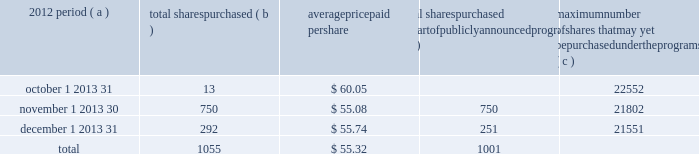Part ii item 5 2013 market for registrant 2019s common equity , related stockholder matters and issuer purchases of equity securities ( a ) ( 1 ) our common stock is listed on the new york stock exchange and is traded under the symbol 201cpnc . 201d at the close of business on february 15 , 2013 , there were 75100 common shareholders of record .
Holders of pnc common stock are entitled to receive dividends when declared by the board of directors out of funds legally available for this purpose .
Our board of directors may not pay or set apart dividends on the common stock until dividends for all past dividend periods on any series of outstanding preferred stock have been paid or declared and set apart for payment .
The board presently intends to continue the policy of paying quarterly cash dividends .
The amount of any future dividends will depend on economic and market conditions , our financial condition and operating results , and other factors , including contractual restrictions and applicable government regulations and policies ( such as those relating to the ability of bank and non- bank subsidiaries to pay dividends to the parent company and regulatory capital limitations ) .
The amount of our dividend is also currently subject to the results of the federal reserve 2019s 2013 comprehensive capital analysis and review ( ccar ) as part of its supervisory assessment of capital adequacy described under 201csupervision and regulation 201d in item 1 of this report .
The federal reserve has the power to prohibit us from paying dividends without its approval .
For further information concerning dividend restrictions and restrictions on loans , dividends or advances from bank subsidiaries to the parent company , see 201csupervision and regulation 201d in item 1 of this report , 201cfunding and capital sources 201d in the consolidated balance sheet review section , 201cliquidity risk management 201d in the risk management section , and 201ctrust preferred securities 201d in the off-balance sheet arrangements and variable interest entities section of item 7 of this report , and note 14 capital securities of subsidiary trusts and perpetual trust securities and note 22 regulatory matters in the notes to consolidated financial statements in item 8 of this report , which we include here by reference .
We include here by reference additional information relating to pnc common stock under the caption 201ccommon stock prices/dividends declared 201d in the statistical information ( unaudited ) section of item 8 of this report .
We include here by reference the information regarding our compensation plans under which pnc equity securities are authorized for issuance as of december 31 , 2012 in the table ( with introductory paragraph and notes ) that appears in item 12 of this report .
Our registrar , stock transfer agent , and dividend disbursing agent is : computershare trust company , n.a .
250 royall street canton , ma 02021 800-982-7652 we include here by reference the information that appears under the caption 201ccommon stock performance graph 201d at the end of this item 5 .
( a ) ( 2 ) none .
( b ) not applicable .
( c ) details of our repurchases of pnc common stock during the fourth quarter of 2012 are included in the table : in thousands , except per share data 2012 period ( a ) total shares purchased ( b ) average paid per total shares purchased as part of publicly announced programs ( c ) maximum number of shares that may yet be purchased under the programs ( c ) .
( a ) in addition to the repurchases of pnc common stock during the fourth quarter of 2012 included in the table above , pnc redeemed all 5001 shares of its series m preferred stock on december 10 , 2012 as further described below .
As part of the national city transaction , we established the pnc non-cumulative perpetual preferred stock , series m ( the 201cseries m preferred stock 201d ) , which mirrored in all material respects the former national city non-cumulative perpetual preferred stock , series e .
On december 10 , 2012 , pnc issued $ 500.1 million aggregate liquidation amount ( 5001 shares ) of the series m preferred stock to the national city preferred capital trust i ( the 201ctrust 201d ) as required pursuant to the settlement of a stock purchase contract agreement between the trust and pnc dated as of january 30 , 2008 .
Immediately upon such issuance , pnc redeemed all 5001 shares of the series m preferred stock from the trust on december 10 , 2012 at a redemption price equal to $ 100000 per share .
( b ) includes pnc common stock purchased under the program referred to in note ( c ) to this table and pnc common stock purchased in connection with our various employee benefit plans .
Note 15 employee benefit plans and note 16 stock based compensation plans in the notes to consolidated financial statements in item 8 of this report include additional information regarding our employee benefit plans that use pnc common stock .
( c ) our current stock repurchase program allows us to purchase up to 25 million shares on the open market or in privately negotiated transactions .
This program was authorized on october 4 , 2007 and will remain in effect until fully utilized or until modified , superseded or terminated .
The extent and timing of share repurchases under this program will depend on a number of factors including , among others , market and general economic conditions , economic capital and regulatory capital considerations , alternative uses of capital , the potential impact on our credit ratings , and contractual and regulatory limitations , including the impact of the federal reserve 2019s supervisory assessment of capital adequacy program .
The pnc financial services group , inc .
2013 form 10-k 27 .
When pnc redeemed all shares of the series m preferred stock from the trust on december 10 , 2012 , what was the total cash cost of the redemption? 
Computations: (5001 * 100000)
Answer: 500100000.0. Part ii item 5 2013 market for registrant 2019s common equity , related stockholder matters and issuer purchases of equity securities ( a ) ( 1 ) our common stock is listed on the new york stock exchange and is traded under the symbol 201cpnc . 201d at the close of business on february 15 , 2013 , there were 75100 common shareholders of record .
Holders of pnc common stock are entitled to receive dividends when declared by the board of directors out of funds legally available for this purpose .
Our board of directors may not pay or set apart dividends on the common stock until dividends for all past dividend periods on any series of outstanding preferred stock have been paid or declared and set apart for payment .
The board presently intends to continue the policy of paying quarterly cash dividends .
The amount of any future dividends will depend on economic and market conditions , our financial condition and operating results , and other factors , including contractual restrictions and applicable government regulations and policies ( such as those relating to the ability of bank and non- bank subsidiaries to pay dividends to the parent company and regulatory capital limitations ) .
The amount of our dividend is also currently subject to the results of the federal reserve 2019s 2013 comprehensive capital analysis and review ( ccar ) as part of its supervisory assessment of capital adequacy described under 201csupervision and regulation 201d in item 1 of this report .
The federal reserve has the power to prohibit us from paying dividends without its approval .
For further information concerning dividend restrictions and restrictions on loans , dividends or advances from bank subsidiaries to the parent company , see 201csupervision and regulation 201d in item 1 of this report , 201cfunding and capital sources 201d in the consolidated balance sheet review section , 201cliquidity risk management 201d in the risk management section , and 201ctrust preferred securities 201d in the off-balance sheet arrangements and variable interest entities section of item 7 of this report , and note 14 capital securities of subsidiary trusts and perpetual trust securities and note 22 regulatory matters in the notes to consolidated financial statements in item 8 of this report , which we include here by reference .
We include here by reference additional information relating to pnc common stock under the caption 201ccommon stock prices/dividends declared 201d in the statistical information ( unaudited ) section of item 8 of this report .
We include here by reference the information regarding our compensation plans under which pnc equity securities are authorized for issuance as of december 31 , 2012 in the table ( with introductory paragraph and notes ) that appears in item 12 of this report .
Our registrar , stock transfer agent , and dividend disbursing agent is : computershare trust company , n.a .
250 royall street canton , ma 02021 800-982-7652 we include here by reference the information that appears under the caption 201ccommon stock performance graph 201d at the end of this item 5 .
( a ) ( 2 ) none .
( b ) not applicable .
( c ) details of our repurchases of pnc common stock during the fourth quarter of 2012 are included in the table : in thousands , except per share data 2012 period ( a ) total shares purchased ( b ) average paid per total shares purchased as part of publicly announced programs ( c ) maximum number of shares that may yet be purchased under the programs ( c ) .
( a ) in addition to the repurchases of pnc common stock during the fourth quarter of 2012 included in the table above , pnc redeemed all 5001 shares of its series m preferred stock on december 10 , 2012 as further described below .
As part of the national city transaction , we established the pnc non-cumulative perpetual preferred stock , series m ( the 201cseries m preferred stock 201d ) , which mirrored in all material respects the former national city non-cumulative perpetual preferred stock , series e .
On december 10 , 2012 , pnc issued $ 500.1 million aggregate liquidation amount ( 5001 shares ) of the series m preferred stock to the national city preferred capital trust i ( the 201ctrust 201d ) as required pursuant to the settlement of a stock purchase contract agreement between the trust and pnc dated as of january 30 , 2008 .
Immediately upon such issuance , pnc redeemed all 5001 shares of the series m preferred stock from the trust on december 10 , 2012 at a redemption price equal to $ 100000 per share .
( b ) includes pnc common stock purchased under the program referred to in note ( c ) to this table and pnc common stock purchased in connection with our various employee benefit plans .
Note 15 employee benefit plans and note 16 stock based compensation plans in the notes to consolidated financial statements in item 8 of this report include additional information regarding our employee benefit plans that use pnc common stock .
( c ) our current stock repurchase program allows us to purchase up to 25 million shares on the open market or in privately negotiated transactions .
This program was authorized on october 4 , 2007 and will remain in effect until fully utilized or until modified , superseded or terminated .
The extent and timing of share repurchases under this program will depend on a number of factors including , among others , market and general economic conditions , economic capital and regulatory capital considerations , alternative uses of capital , the potential impact on our credit ratings , and contractual and regulatory limitations , including the impact of the federal reserve 2019s supervisory assessment of capital adequacy program .
The pnc financial services group , inc .
2013 form 10-k 27 .
What percentage of the total shares purchased were not purchased in october? 
Computations: ((750 + 292) / 1055)
Answer: 0.98768. Part ii item 5 2013 market for registrant 2019s common equity , related stockholder matters and issuer purchases of equity securities ( a ) ( 1 ) our common stock is listed on the new york stock exchange and is traded under the symbol 201cpnc . 201d at the close of business on february 15 , 2013 , there were 75100 common shareholders of record .
Holders of pnc common stock are entitled to receive dividends when declared by the board of directors out of funds legally available for this purpose .
Our board of directors may not pay or set apart dividends on the common stock until dividends for all past dividend periods on any series of outstanding preferred stock have been paid or declared and set apart for payment .
The board presently intends to continue the policy of paying quarterly cash dividends .
The amount of any future dividends will depend on economic and market conditions , our financial condition and operating results , and other factors , including contractual restrictions and applicable government regulations and policies ( such as those relating to the ability of bank and non- bank subsidiaries to pay dividends to the parent company and regulatory capital limitations ) .
The amount of our dividend is also currently subject to the results of the federal reserve 2019s 2013 comprehensive capital analysis and review ( ccar ) as part of its supervisory assessment of capital adequacy described under 201csupervision and regulation 201d in item 1 of this report .
The federal reserve has the power to prohibit us from paying dividends without its approval .
For further information concerning dividend restrictions and restrictions on loans , dividends or advances from bank subsidiaries to the parent company , see 201csupervision and regulation 201d in item 1 of this report , 201cfunding and capital sources 201d in the consolidated balance sheet review section , 201cliquidity risk management 201d in the risk management section , and 201ctrust preferred securities 201d in the off-balance sheet arrangements and variable interest entities section of item 7 of this report , and note 14 capital securities of subsidiary trusts and perpetual trust securities and note 22 regulatory matters in the notes to consolidated financial statements in item 8 of this report , which we include here by reference .
We include here by reference additional information relating to pnc common stock under the caption 201ccommon stock prices/dividends declared 201d in the statistical information ( unaudited ) section of item 8 of this report .
We include here by reference the information regarding our compensation plans under which pnc equity securities are authorized for issuance as of december 31 , 2012 in the table ( with introductory paragraph and notes ) that appears in item 12 of this report .
Our registrar , stock transfer agent , and dividend disbursing agent is : computershare trust company , n.a .
250 royall street canton , ma 02021 800-982-7652 we include here by reference the information that appears under the caption 201ccommon stock performance graph 201d at the end of this item 5 .
( a ) ( 2 ) none .
( b ) not applicable .
( c ) details of our repurchases of pnc common stock during the fourth quarter of 2012 are included in the table : in thousands , except per share data 2012 period ( a ) total shares purchased ( b ) average paid per total shares purchased as part of publicly announced programs ( c ) maximum number of shares that may yet be purchased under the programs ( c ) .
( a ) in addition to the repurchases of pnc common stock during the fourth quarter of 2012 included in the table above , pnc redeemed all 5001 shares of its series m preferred stock on december 10 , 2012 as further described below .
As part of the national city transaction , we established the pnc non-cumulative perpetual preferred stock , series m ( the 201cseries m preferred stock 201d ) , which mirrored in all material respects the former national city non-cumulative perpetual preferred stock , series e .
On december 10 , 2012 , pnc issued $ 500.1 million aggregate liquidation amount ( 5001 shares ) of the series m preferred stock to the national city preferred capital trust i ( the 201ctrust 201d ) as required pursuant to the settlement of a stock purchase contract agreement between the trust and pnc dated as of january 30 , 2008 .
Immediately upon such issuance , pnc redeemed all 5001 shares of the series m preferred stock from the trust on december 10 , 2012 at a redemption price equal to $ 100000 per share .
( b ) includes pnc common stock purchased under the program referred to in note ( c ) to this table and pnc common stock purchased in connection with our various employee benefit plans .
Note 15 employee benefit plans and note 16 stock based compensation plans in the notes to consolidated financial statements in item 8 of this report include additional information regarding our employee benefit plans that use pnc common stock .
( c ) our current stock repurchase program allows us to purchase up to 25 million shares on the open market or in privately negotiated transactions .
This program was authorized on october 4 , 2007 and will remain in effect until fully utilized or until modified , superseded or terminated .
The extent and timing of share repurchases under this program will depend on a number of factors including , among others , market and general economic conditions , economic capital and regulatory capital considerations , alternative uses of capital , the potential impact on our credit ratings , and contractual and regulatory limitations , including the impact of the federal reserve 2019s supervisory assessment of capital adequacy program .
The pnc financial services group , inc .
2013 form 10-k 27 .
For the fourth quarter of 2012 what as the percent of the total shares purchased that was bought in december? 
Computations: (292 / 1055)
Answer: 0.27678. Part ii item 5 2013 market for registrant 2019s common equity , related stockholder matters and issuer purchases of equity securities ( a ) ( 1 ) our common stock is listed on the new york stock exchange and is traded under the symbol 201cpnc . 201d at the close of business on february 15 , 2013 , there were 75100 common shareholders of record .
Holders of pnc common stock are entitled to receive dividends when declared by the board of directors out of funds legally available for this purpose .
Our board of directors may not pay or set apart dividends on the common stock until dividends for all past dividend periods on any series of outstanding preferred stock have been paid or declared and set apart for payment .
The board presently intends to continue the policy of paying quarterly cash dividends .
The amount of any future dividends will depend on economic and market conditions , our financial condition and operating results , and other factors , including contractual restrictions and applicable government regulations and policies ( such as those relating to the ability of bank and non- bank subsidiaries to pay dividends to the parent company and regulatory capital limitations ) .
The amount of our dividend is also currently subject to the results of the federal reserve 2019s 2013 comprehensive capital analysis and review ( ccar ) as part of its supervisory assessment of capital adequacy described under 201csupervision and regulation 201d in item 1 of this report .
The federal reserve has the power to prohibit us from paying dividends without its approval .
For further information concerning dividend restrictions and restrictions on loans , dividends or advances from bank subsidiaries to the parent company , see 201csupervision and regulation 201d in item 1 of this report , 201cfunding and capital sources 201d in the consolidated balance sheet review section , 201cliquidity risk management 201d in the risk management section , and 201ctrust preferred securities 201d in the off-balance sheet arrangements and variable interest entities section of item 7 of this report , and note 14 capital securities of subsidiary trusts and perpetual trust securities and note 22 regulatory matters in the notes to consolidated financial statements in item 8 of this report , which we include here by reference .
We include here by reference additional information relating to pnc common stock under the caption 201ccommon stock prices/dividends declared 201d in the statistical information ( unaudited ) section of item 8 of this report .
We include here by reference the information regarding our compensation plans under which pnc equity securities are authorized for issuance as of december 31 , 2012 in the table ( with introductory paragraph and notes ) that appears in item 12 of this report .
Our registrar , stock transfer agent , and dividend disbursing agent is : computershare trust company , n.a .
250 royall street canton , ma 02021 800-982-7652 we include here by reference the information that appears under the caption 201ccommon stock performance graph 201d at the end of this item 5 .
( a ) ( 2 ) none .
( b ) not applicable .
( c ) details of our repurchases of pnc common stock during the fourth quarter of 2012 are included in the table : in thousands , except per share data 2012 period ( a ) total shares purchased ( b ) average paid per total shares purchased as part of publicly announced programs ( c ) maximum number of shares that may yet be purchased under the programs ( c ) .
( a ) in addition to the repurchases of pnc common stock during the fourth quarter of 2012 included in the table above , pnc redeemed all 5001 shares of its series m preferred stock on december 10 , 2012 as further described below .
As part of the national city transaction , we established the pnc non-cumulative perpetual preferred stock , series m ( the 201cseries m preferred stock 201d ) , which mirrored in all material respects the former national city non-cumulative perpetual preferred stock , series e .
On december 10 , 2012 , pnc issued $ 500.1 million aggregate liquidation amount ( 5001 shares ) of the series m preferred stock to the national city preferred capital trust i ( the 201ctrust 201d ) as required pursuant to the settlement of a stock purchase contract agreement between the trust and pnc dated as of january 30 , 2008 .
Immediately upon such issuance , pnc redeemed all 5001 shares of the series m preferred stock from the trust on december 10 , 2012 at a redemption price equal to $ 100000 per share .
( b ) includes pnc common stock purchased under the program referred to in note ( c ) to this table and pnc common stock purchased in connection with our various employee benefit plans .
Note 15 employee benefit plans and note 16 stock based compensation plans in the notes to consolidated financial statements in item 8 of this report include additional information regarding our employee benefit plans that use pnc common stock .
( c ) our current stock repurchase program allows us to purchase up to 25 million shares on the open market or in privately negotiated transactions .
This program was authorized on october 4 , 2007 and will remain in effect until fully utilized or until modified , superseded or terminated .
The extent and timing of share repurchases under this program will depend on a number of factors including , among others , market and general economic conditions , economic capital and regulatory capital considerations , alternative uses of capital , the potential impact on our credit ratings , and contractual and regulatory limitations , including the impact of the federal reserve 2019s supervisory assessment of capital adequacy program .
The pnc financial services group , inc .
2013 form 10-k 27 .
In addition to the repurchases of pnc common stock during the fourth quarter of 2012 , what were total number of shares repurchased including shares of series m preferred stock redeemed on december 10 , 2012? 
Computations: (1055 + 5001)
Answer: 6056.0. 